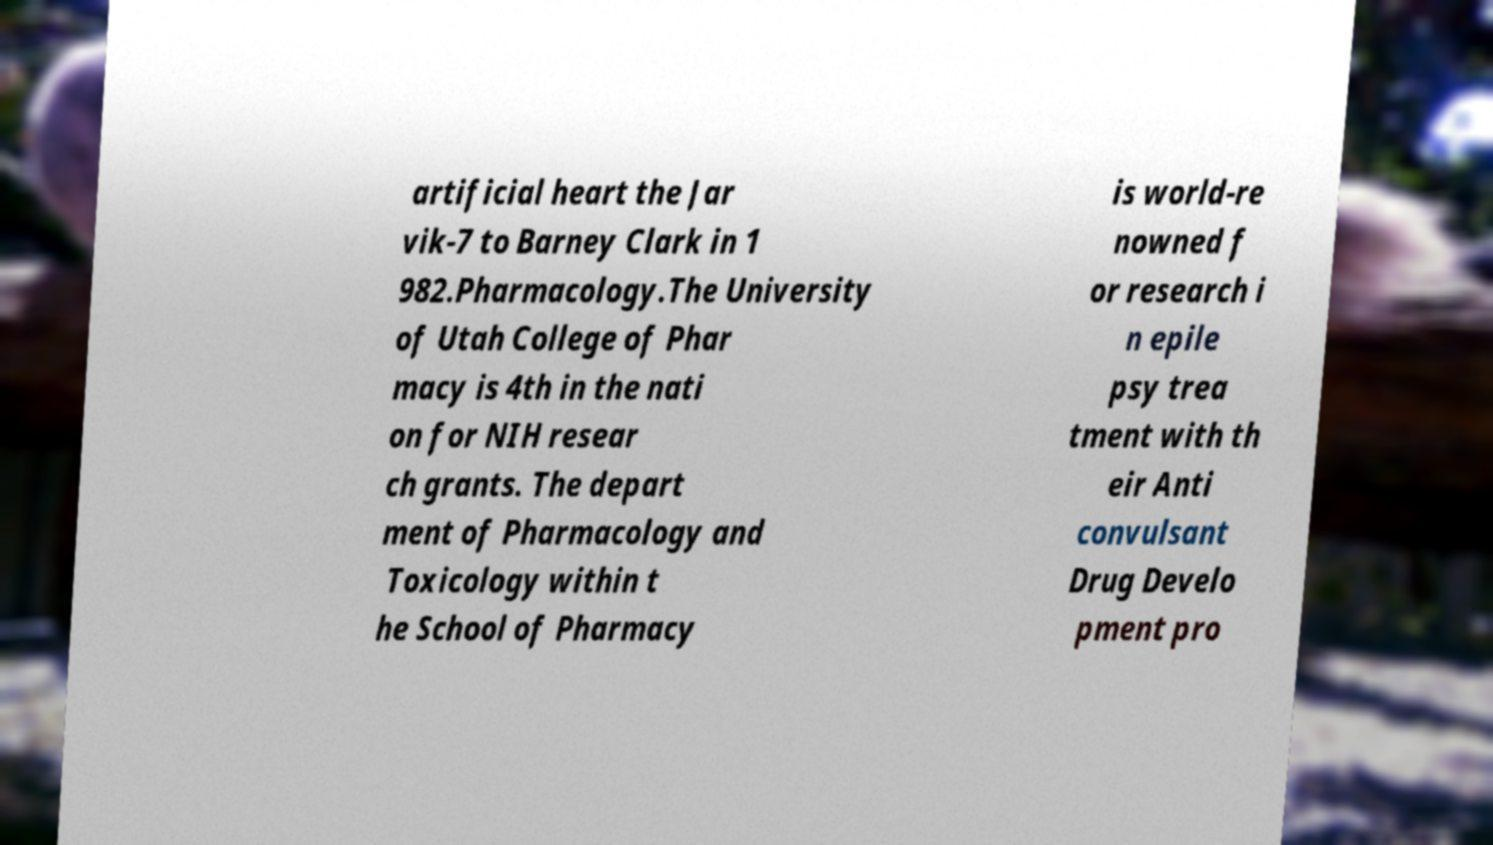Can you read and provide the text displayed in the image?This photo seems to have some interesting text. Can you extract and type it out for me? artificial heart the Jar vik-7 to Barney Clark in 1 982.Pharmacology.The University of Utah College of Phar macy is 4th in the nati on for NIH resear ch grants. The depart ment of Pharmacology and Toxicology within t he School of Pharmacy is world-re nowned f or research i n epile psy trea tment with th eir Anti convulsant Drug Develo pment pro 